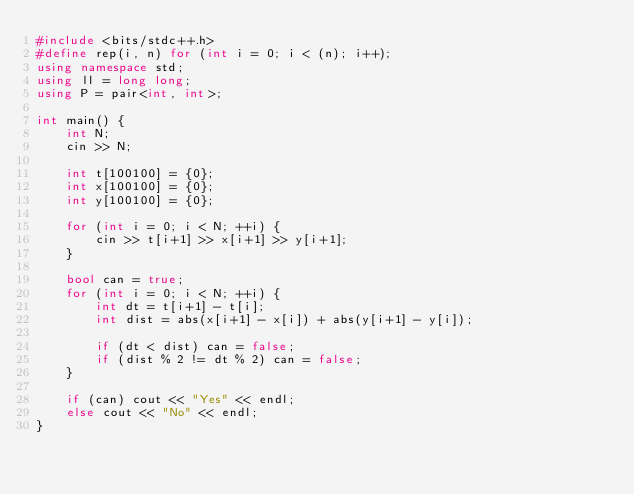Convert code to text. <code><loc_0><loc_0><loc_500><loc_500><_C++_>#include <bits/stdc++.h>
#define rep(i, n) for (int i = 0; i < (n); i++);
using namespace std;
using ll = long long;
using P = pair<int, int>;

int main() {
    int N;
    cin >> N;

    int t[100100] = {0};
    int x[100100] = {0};
    int y[100100] = {0};

    for (int i = 0; i < N; ++i) {
        cin >> t[i+1] >> x[i+1] >> y[i+1]; 
    }

    bool can = true;
    for (int i = 0; i < N; ++i) {
        int dt = t[i+1] - t[i];
        int dist = abs(x[i+1] - x[i]) + abs(y[i+1] - y[i]);

        if (dt < dist) can = false;
        if (dist % 2 != dt % 2) can = false;
    }

    if (can) cout << "Yes" << endl;
    else cout << "No" << endl;
}</code> 